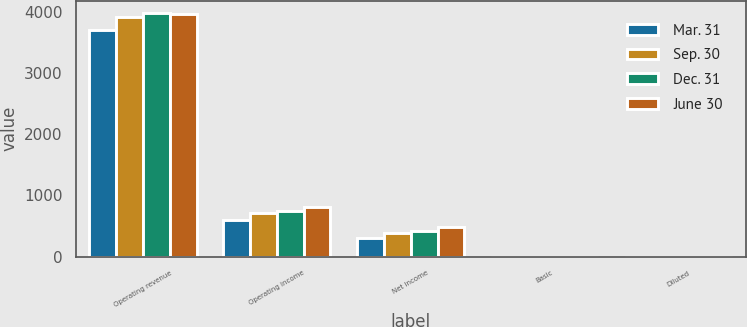Convert chart to OTSL. <chart><loc_0><loc_0><loc_500><loc_500><stacked_bar_chart><ecel><fcel>Operating revenue<fcel>Operating income<fcel>Net income<fcel>Basic<fcel>Diluted<nl><fcel>Mar. 31<fcel>3710<fcel>605<fcel>311<fcel>1.16<fcel>1.15<nl><fcel>Sep. 30<fcel>3923<fcel>717<fcel>390<fcel>1.45<fcel>1.44<nl><fcel>Dec. 31<fcel>3983<fcel>752<fcel>420<fcel>1.56<fcel>1.54<nl><fcel>June 30<fcel>3962<fcel>810<fcel>485<fcel>1.79<fcel>1.78<nl></chart> 